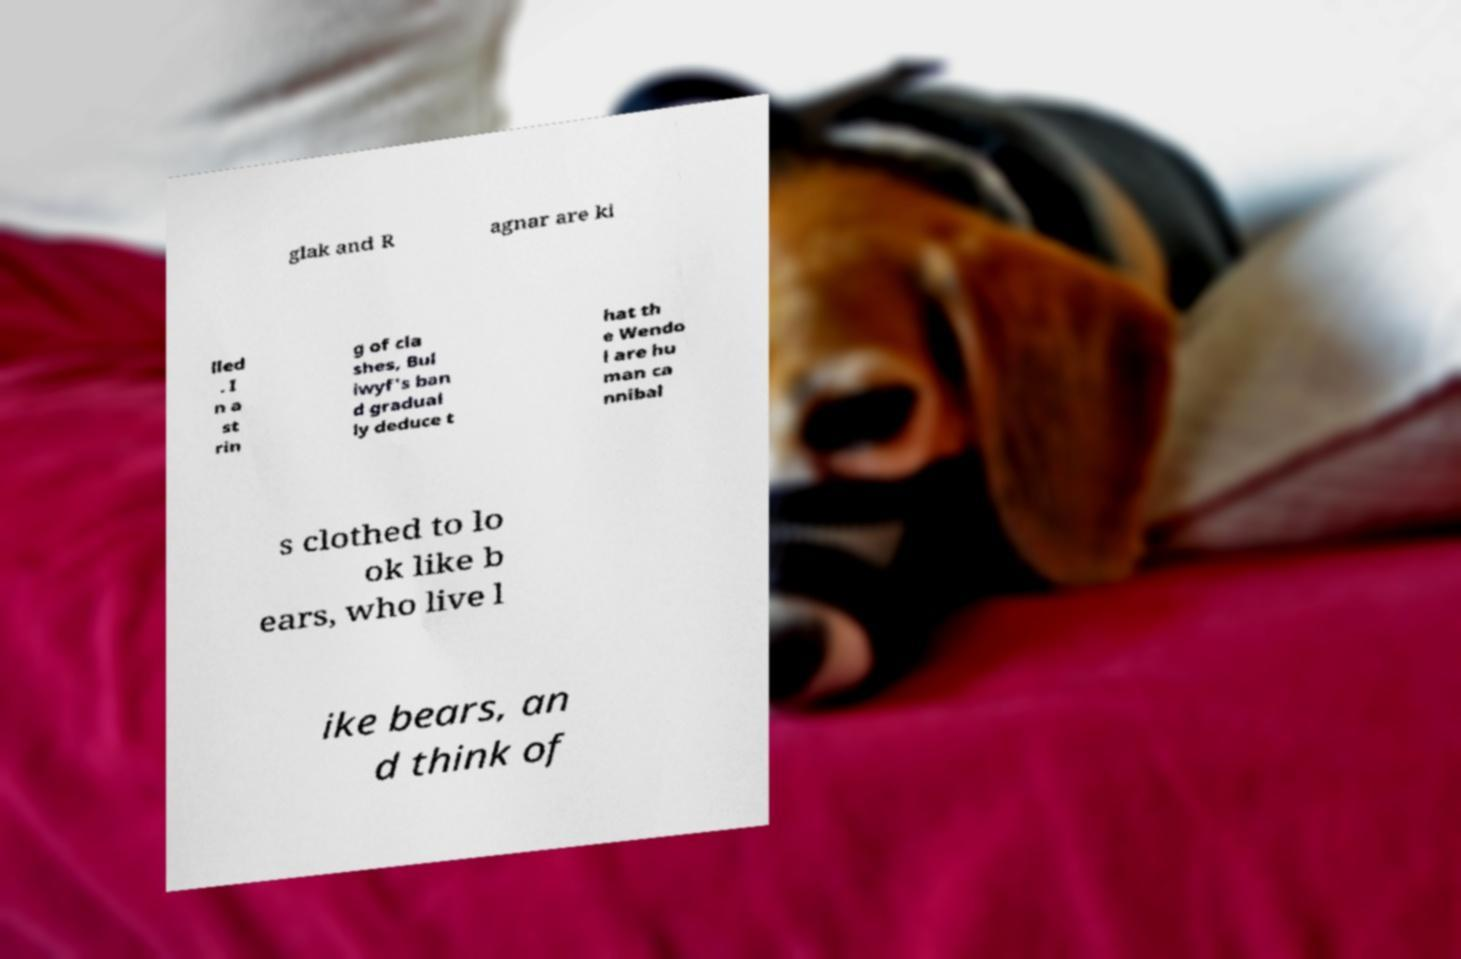Can you read and provide the text displayed in the image?This photo seems to have some interesting text. Can you extract and type it out for me? glak and R agnar are ki lled . I n a st rin g of cla shes, Bul iwyf's ban d gradual ly deduce t hat th e Wendo l are hu man ca nnibal s clothed to lo ok like b ears, who live l ike bears, an d think of 